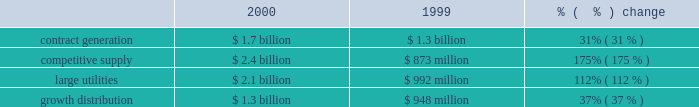Wrote-off debt issuance costs of $ 4 million , which resulted in an extraordinary loss for the early retirement of debt .
Net income net income decreased $ 522 million to $ 273 million in 2001 from $ 795 million in 2000 .
The overall decrease in net income is due to decreased net income from competitive supply and large utility businesses offset slightly by increases in the contract generation and growth distribution businesses .
The decreases are primarily due to lower market prices in the united kingdom and the decline in the brazilian real during 2001 resulting in foreign currency transaction losses of approximately $ 210 million .
Additionally the company recorded severance and transaction costs related to the ipalco pooling-of-interest transaction and a loss from discontinued operations of $ 194 million .
Our 10 largest contributors to net income in 2001 were as follows : lal pir/pak gen , shady point and thames from contract generation ; somerset from competitive supply ; edc , eletropaulo , ipalco , cilcorp and cemig from large utilities ; and sul from growth distribution .
2000 compared to 1999 revenues revenues increased $ 3.4 billion , or 83% ( 83 % ) , to $ 7.5 billion in 2000 from $ 4.1 billion in 1999 .
The increase in revenues is due primarily to the acquisition of new businesses .
Excluding businesses acquired or that commenced commercial operations during 2000 or 1999 , revenues increased 6% ( 6 % ) to $ 3.6 billion. .
Contract generation revenues increased $ 400 million , or 31% ( 31 % ) , to $ 1.7 billion in 2000 from $ 1.3 billion in 1999 .
Excluding businesses acquired or that commenced commercial operations in 2000 or 1999 , contract generation revenues increased 4% ( 4 % ) to $ 1.3 billion in 2000 .
The increase in contract generation segment revenues was due primarily to increases in south america , north america , caribbean and asia , offset by a slight decline in europe/africa .
In south america , contract generation segment revenue increased $ 245 million , and this is due mainly to the acquisition of tiete .
In north america , contract generation segment revenues increased $ 76 million due primarily to the start of commercial operations at warrior run in january 2000 .
In the caribbean , contract generation segment revenues increased $ 92 million due primarily to the start of commercial operations at merida iii in june 2000 and increased revenues from los mina .
In asia , contract generation segment revenue increased $ 41 million due primarily to increased operations at the ecogen peaking plant and lal pir and pak gen in pakistan .
In europe/africa , contract generation segment revenues remained fairly constant with decreases at tisza ii in hungary being offset by the acquisition of a controlling interest at kilroot .
Competitive supply revenues increased $ 1.5 billion , or 175% ( 175 % ) , to $ 2.4 billion in 2000 from $ 873 million in 1999 .
Excluding businesses acquired or that commenced commercial operations in 2000 or 1999 , competitive supply revenues increased 25% ( 25 % ) to $ 477 million in 2000 .
The most significant increases occurred within north america and europe/africa .
Slight increases occurred in south america and the caribbean .
Asia reported a slight decrease .
In north america , competitive supply segment revenues increased $ 610 million due primarily to the new york plants and new energy .
Without foreign currency transaction losses , what would 2001 net income have been in millions? 
Computations: (210 + 273)
Answer: 483.0. 